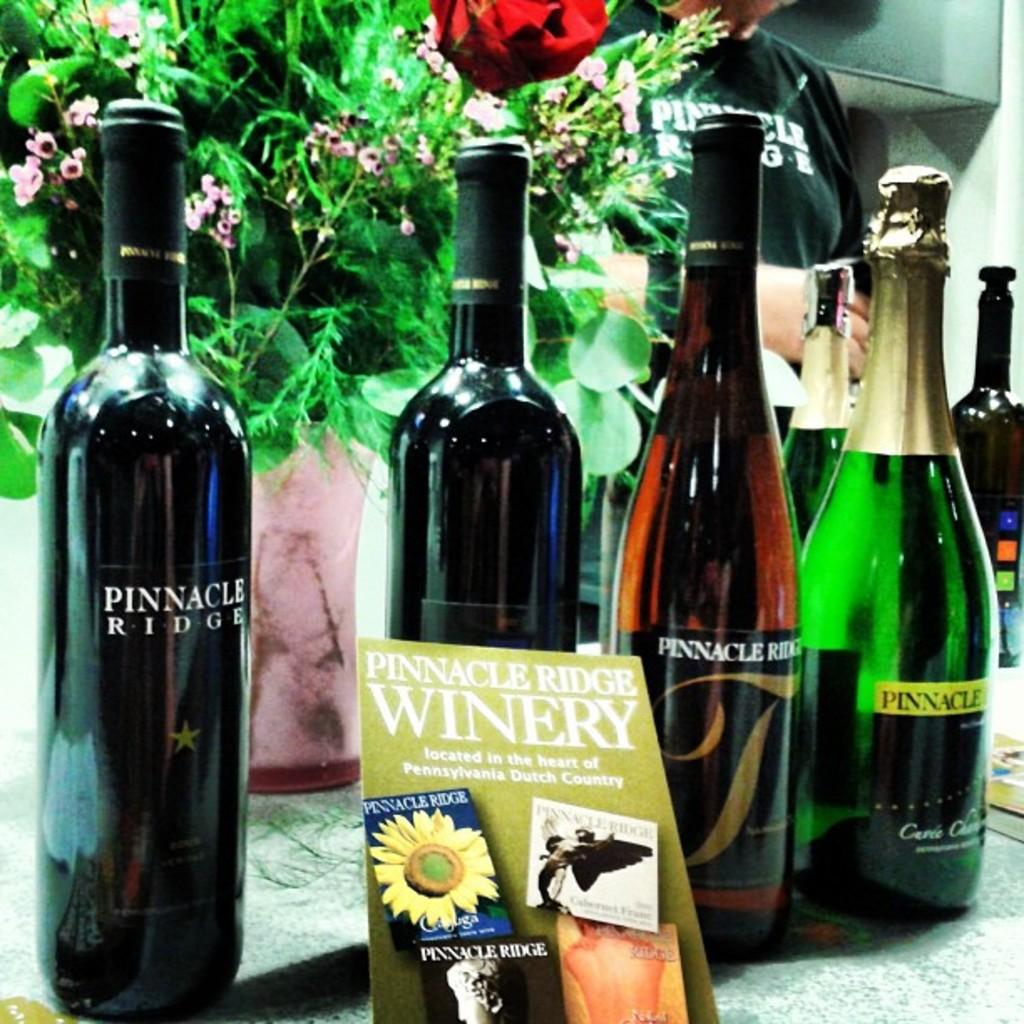<image>
Share a concise interpretation of the image provided. a pamphlet that has pinnacle ridge winery on it 